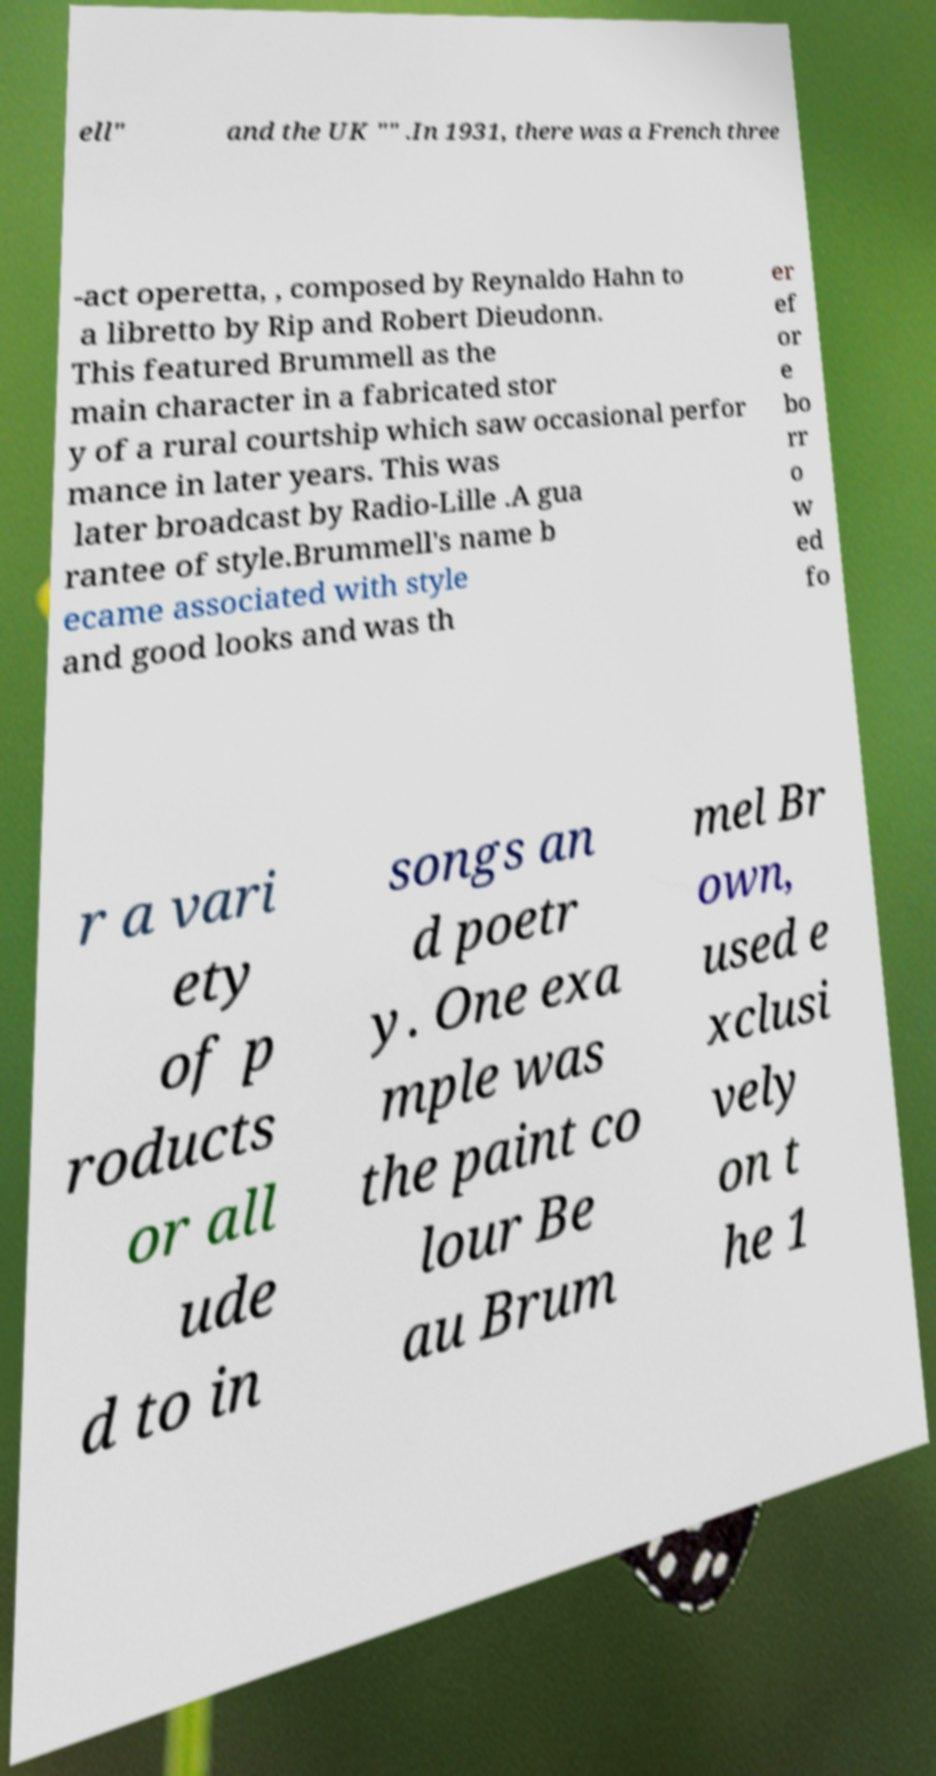I need the written content from this picture converted into text. Can you do that? ell" and the UK "" .In 1931, there was a French three -act operetta, , composed by Reynaldo Hahn to a libretto by Rip and Robert Dieudonn. This featured Brummell as the main character in a fabricated stor y of a rural courtship which saw occasional perfor mance in later years. This was later broadcast by Radio-Lille .A gua rantee of style.Brummell's name b ecame associated with style and good looks and was th er ef or e bo rr o w ed fo r a vari ety of p roducts or all ude d to in songs an d poetr y. One exa mple was the paint co lour Be au Brum mel Br own, used e xclusi vely on t he 1 